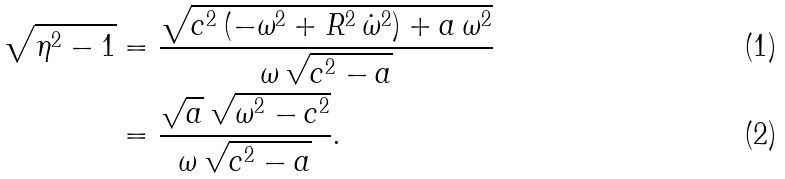Convert formula to latex. <formula><loc_0><loc_0><loc_500><loc_500>\sqrt { \eta ^ { 2 } - 1 } & = \frac { \sqrt { c ^ { 2 } \, ( - \omega ^ { 2 } + R ^ { 2 } \, \dot { \omega } ^ { 2 } ) + a \, \omega ^ { 2 } } } { \omega \, \sqrt { c ^ { 2 } - a } } \\ & = \frac { \sqrt { a } \, \sqrt { \omega ^ { 2 } - c ^ { 2 } } } { \omega \, \sqrt { c ^ { 2 } - a } } .</formula> 